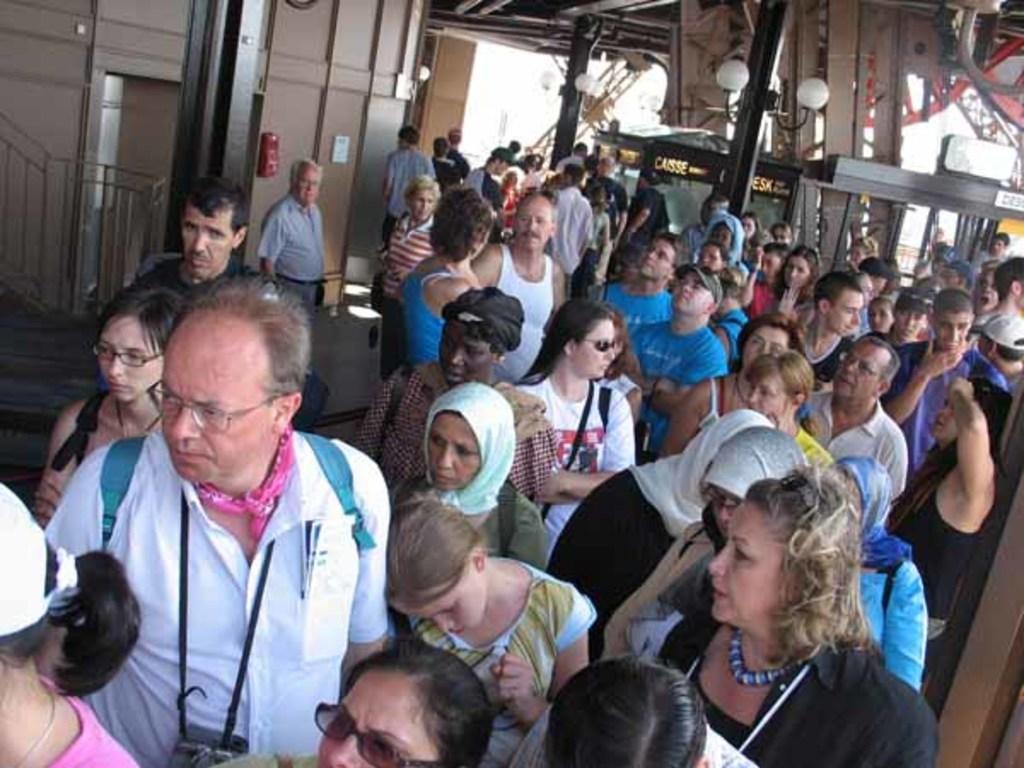In one or two sentences, can you explain what this image depicts? In this image I can see group of people standing. In front the person is wearing white color shirt. In the background I can see few light poles and I can see few cupboards in cream color. 